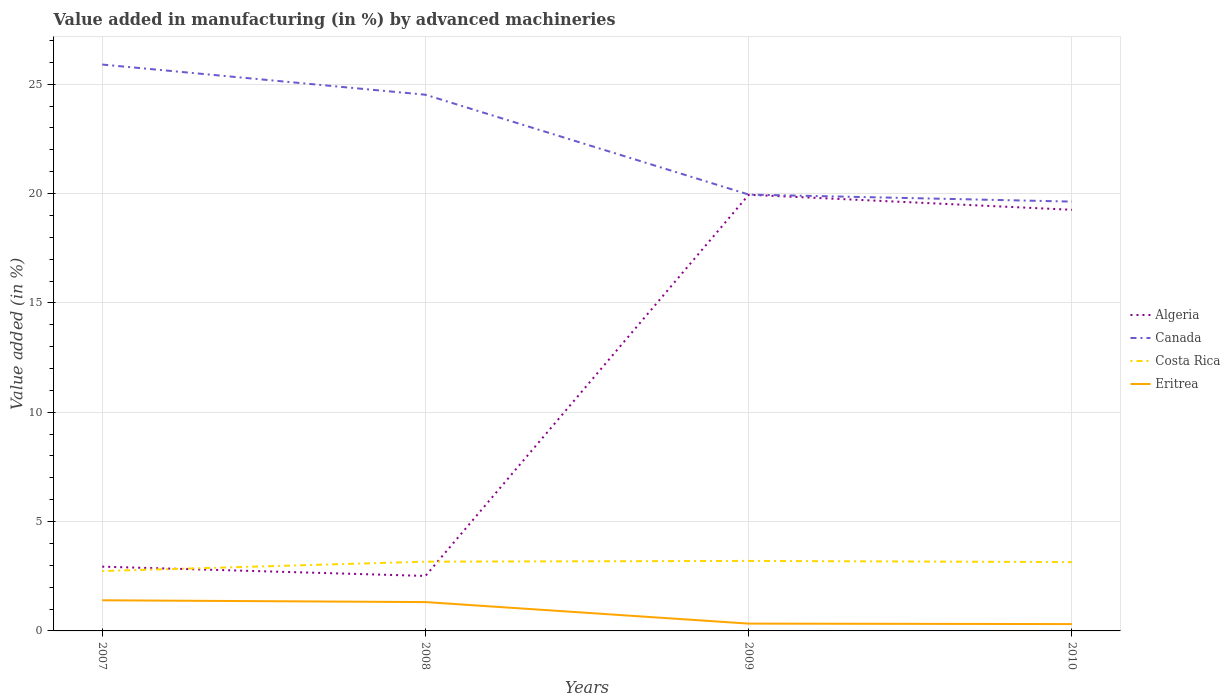How many different coloured lines are there?
Your response must be concise. 4. Does the line corresponding to Canada intersect with the line corresponding to Algeria?
Offer a very short reply. No. Across all years, what is the maximum percentage of value added in manufacturing by advanced machineries in Canada?
Your answer should be compact. 19.63. In which year was the percentage of value added in manufacturing by advanced machineries in Canada maximum?
Offer a terse response. 2010. What is the total percentage of value added in manufacturing by advanced machineries in Canada in the graph?
Your response must be concise. 4.57. What is the difference between the highest and the second highest percentage of value added in manufacturing by advanced machineries in Canada?
Provide a succinct answer. 6.27. What is the difference between the highest and the lowest percentage of value added in manufacturing by advanced machineries in Costa Rica?
Your answer should be very brief. 3. Does the graph contain any zero values?
Offer a terse response. No. How many legend labels are there?
Provide a succinct answer. 4. How are the legend labels stacked?
Offer a very short reply. Vertical. What is the title of the graph?
Provide a succinct answer. Value added in manufacturing (in %) by advanced machineries. Does "Puerto Rico" appear as one of the legend labels in the graph?
Offer a terse response. No. What is the label or title of the X-axis?
Make the answer very short. Years. What is the label or title of the Y-axis?
Provide a succinct answer. Value added (in %). What is the Value added (in %) of Algeria in 2007?
Offer a terse response. 2.94. What is the Value added (in %) in Canada in 2007?
Your answer should be very brief. 25.9. What is the Value added (in %) in Costa Rica in 2007?
Give a very brief answer. 2.74. What is the Value added (in %) of Eritrea in 2007?
Offer a terse response. 1.4. What is the Value added (in %) in Algeria in 2008?
Offer a terse response. 2.51. What is the Value added (in %) in Canada in 2008?
Ensure brevity in your answer.  24.52. What is the Value added (in %) of Costa Rica in 2008?
Provide a short and direct response. 3.17. What is the Value added (in %) of Eritrea in 2008?
Provide a succinct answer. 1.32. What is the Value added (in %) of Algeria in 2009?
Provide a short and direct response. 19.95. What is the Value added (in %) of Canada in 2009?
Provide a short and direct response. 19.96. What is the Value added (in %) in Costa Rica in 2009?
Ensure brevity in your answer.  3.2. What is the Value added (in %) in Eritrea in 2009?
Give a very brief answer. 0.33. What is the Value added (in %) in Algeria in 2010?
Make the answer very short. 19.26. What is the Value added (in %) of Canada in 2010?
Your response must be concise. 19.63. What is the Value added (in %) of Costa Rica in 2010?
Provide a short and direct response. 3.15. What is the Value added (in %) in Eritrea in 2010?
Your answer should be compact. 0.31. Across all years, what is the maximum Value added (in %) in Algeria?
Offer a very short reply. 19.95. Across all years, what is the maximum Value added (in %) in Canada?
Your answer should be compact. 25.9. Across all years, what is the maximum Value added (in %) of Costa Rica?
Offer a very short reply. 3.2. Across all years, what is the maximum Value added (in %) in Eritrea?
Your response must be concise. 1.4. Across all years, what is the minimum Value added (in %) of Algeria?
Keep it short and to the point. 2.51. Across all years, what is the minimum Value added (in %) of Canada?
Provide a short and direct response. 19.63. Across all years, what is the minimum Value added (in %) of Costa Rica?
Offer a very short reply. 2.74. Across all years, what is the minimum Value added (in %) of Eritrea?
Your answer should be very brief. 0.31. What is the total Value added (in %) in Algeria in the graph?
Your answer should be compact. 44.66. What is the total Value added (in %) of Canada in the graph?
Your answer should be compact. 90.01. What is the total Value added (in %) in Costa Rica in the graph?
Provide a succinct answer. 12.25. What is the total Value added (in %) in Eritrea in the graph?
Provide a succinct answer. 3.37. What is the difference between the Value added (in %) in Algeria in 2007 and that in 2008?
Offer a very short reply. 0.42. What is the difference between the Value added (in %) of Canada in 2007 and that in 2008?
Keep it short and to the point. 1.38. What is the difference between the Value added (in %) of Costa Rica in 2007 and that in 2008?
Give a very brief answer. -0.43. What is the difference between the Value added (in %) of Eritrea in 2007 and that in 2008?
Make the answer very short. 0.08. What is the difference between the Value added (in %) in Algeria in 2007 and that in 2009?
Your answer should be very brief. -17.01. What is the difference between the Value added (in %) of Canada in 2007 and that in 2009?
Make the answer very short. 5.95. What is the difference between the Value added (in %) of Costa Rica in 2007 and that in 2009?
Give a very brief answer. -0.46. What is the difference between the Value added (in %) of Eritrea in 2007 and that in 2009?
Your answer should be compact. 1.07. What is the difference between the Value added (in %) of Algeria in 2007 and that in 2010?
Your answer should be compact. -16.32. What is the difference between the Value added (in %) in Canada in 2007 and that in 2010?
Provide a succinct answer. 6.27. What is the difference between the Value added (in %) in Costa Rica in 2007 and that in 2010?
Provide a short and direct response. -0.41. What is the difference between the Value added (in %) of Eritrea in 2007 and that in 2010?
Your response must be concise. 1.09. What is the difference between the Value added (in %) of Algeria in 2008 and that in 2009?
Provide a short and direct response. -17.43. What is the difference between the Value added (in %) of Canada in 2008 and that in 2009?
Make the answer very short. 4.57. What is the difference between the Value added (in %) of Costa Rica in 2008 and that in 2009?
Keep it short and to the point. -0.03. What is the difference between the Value added (in %) in Eritrea in 2008 and that in 2009?
Keep it short and to the point. 0.98. What is the difference between the Value added (in %) in Algeria in 2008 and that in 2010?
Offer a terse response. -16.74. What is the difference between the Value added (in %) of Canada in 2008 and that in 2010?
Offer a very short reply. 4.89. What is the difference between the Value added (in %) of Costa Rica in 2008 and that in 2010?
Keep it short and to the point. 0.02. What is the difference between the Value added (in %) in Algeria in 2009 and that in 2010?
Keep it short and to the point. 0.69. What is the difference between the Value added (in %) of Canada in 2009 and that in 2010?
Make the answer very short. 0.32. What is the difference between the Value added (in %) of Costa Rica in 2009 and that in 2010?
Your response must be concise. 0.05. What is the difference between the Value added (in %) in Eritrea in 2009 and that in 2010?
Make the answer very short. 0.02. What is the difference between the Value added (in %) of Algeria in 2007 and the Value added (in %) of Canada in 2008?
Ensure brevity in your answer.  -21.58. What is the difference between the Value added (in %) of Algeria in 2007 and the Value added (in %) of Costa Rica in 2008?
Your response must be concise. -0.23. What is the difference between the Value added (in %) of Algeria in 2007 and the Value added (in %) of Eritrea in 2008?
Keep it short and to the point. 1.62. What is the difference between the Value added (in %) of Canada in 2007 and the Value added (in %) of Costa Rica in 2008?
Offer a terse response. 22.73. What is the difference between the Value added (in %) of Canada in 2007 and the Value added (in %) of Eritrea in 2008?
Give a very brief answer. 24.58. What is the difference between the Value added (in %) in Costa Rica in 2007 and the Value added (in %) in Eritrea in 2008?
Make the answer very short. 1.42. What is the difference between the Value added (in %) of Algeria in 2007 and the Value added (in %) of Canada in 2009?
Your response must be concise. -17.02. What is the difference between the Value added (in %) of Algeria in 2007 and the Value added (in %) of Costa Rica in 2009?
Keep it short and to the point. -0.26. What is the difference between the Value added (in %) of Algeria in 2007 and the Value added (in %) of Eritrea in 2009?
Your response must be concise. 2.6. What is the difference between the Value added (in %) in Canada in 2007 and the Value added (in %) in Costa Rica in 2009?
Your answer should be very brief. 22.7. What is the difference between the Value added (in %) in Canada in 2007 and the Value added (in %) in Eritrea in 2009?
Provide a succinct answer. 25.57. What is the difference between the Value added (in %) of Costa Rica in 2007 and the Value added (in %) of Eritrea in 2009?
Offer a very short reply. 2.4. What is the difference between the Value added (in %) in Algeria in 2007 and the Value added (in %) in Canada in 2010?
Give a very brief answer. -16.69. What is the difference between the Value added (in %) of Algeria in 2007 and the Value added (in %) of Costa Rica in 2010?
Offer a very short reply. -0.21. What is the difference between the Value added (in %) of Algeria in 2007 and the Value added (in %) of Eritrea in 2010?
Make the answer very short. 2.63. What is the difference between the Value added (in %) in Canada in 2007 and the Value added (in %) in Costa Rica in 2010?
Offer a very short reply. 22.75. What is the difference between the Value added (in %) of Canada in 2007 and the Value added (in %) of Eritrea in 2010?
Ensure brevity in your answer.  25.59. What is the difference between the Value added (in %) in Costa Rica in 2007 and the Value added (in %) in Eritrea in 2010?
Keep it short and to the point. 2.43. What is the difference between the Value added (in %) of Algeria in 2008 and the Value added (in %) of Canada in 2009?
Keep it short and to the point. -17.44. What is the difference between the Value added (in %) of Algeria in 2008 and the Value added (in %) of Costa Rica in 2009?
Your response must be concise. -0.69. What is the difference between the Value added (in %) of Algeria in 2008 and the Value added (in %) of Eritrea in 2009?
Make the answer very short. 2.18. What is the difference between the Value added (in %) of Canada in 2008 and the Value added (in %) of Costa Rica in 2009?
Keep it short and to the point. 21.32. What is the difference between the Value added (in %) of Canada in 2008 and the Value added (in %) of Eritrea in 2009?
Ensure brevity in your answer.  24.19. What is the difference between the Value added (in %) of Costa Rica in 2008 and the Value added (in %) of Eritrea in 2009?
Provide a short and direct response. 2.83. What is the difference between the Value added (in %) of Algeria in 2008 and the Value added (in %) of Canada in 2010?
Offer a terse response. -17.12. What is the difference between the Value added (in %) of Algeria in 2008 and the Value added (in %) of Costa Rica in 2010?
Your answer should be very brief. -0.63. What is the difference between the Value added (in %) of Algeria in 2008 and the Value added (in %) of Eritrea in 2010?
Your answer should be compact. 2.2. What is the difference between the Value added (in %) in Canada in 2008 and the Value added (in %) in Costa Rica in 2010?
Give a very brief answer. 21.37. What is the difference between the Value added (in %) of Canada in 2008 and the Value added (in %) of Eritrea in 2010?
Your answer should be compact. 24.21. What is the difference between the Value added (in %) of Costa Rica in 2008 and the Value added (in %) of Eritrea in 2010?
Offer a terse response. 2.85. What is the difference between the Value added (in %) in Algeria in 2009 and the Value added (in %) in Canada in 2010?
Provide a short and direct response. 0.31. What is the difference between the Value added (in %) in Algeria in 2009 and the Value added (in %) in Costa Rica in 2010?
Your answer should be very brief. 16.8. What is the difference between the Value added (in %) of Algeria in 2009 and the Value added (in %) of Eritrea in 2010?
Give a very brief answer. 19.63. What is the difference between the Value added (in %) of Canada in 2009 and the Value added (in %) of Costa Rica in 2010?
Offer a terse response. 16.81. What is the difference between the Value added (in %) of Canada in 2009 and the Value added (in %) of Eritrea in 2010?
Keep it short and to the point. 19.64. What is the difference between the Value added (in %) of Costa Rica in 2009 and the Value added (in %) of Eritrea in 2010?
Provide a short and direct response. 2.89. What is the average Value added (in %) in Algeria per year?
Provide a succinct answer. 11.16. What is the average Value added (in %) of Canada per year?
Keep it short and to the point. 22.5. What is the average Value added (in %) of Costa Rica per year?
Your answer should be very brief. 3.06. What is the average Value added (in %) in Eritrea per year?
Make the answer very short. 0.84. In the year 2007, what is the difference between the Value added (in %) in Algeria and Value added (in %) in Canada?
Your answer should be very brief. -22.96. In the year 2007, what is the difference between the Value added (in %) in Algeria and Value added (in %) in Costa Rica?
Offer a terse response. 0.2. In the year 2007, what is the difference between the Value added (in %) of Algeria and Value added (in %) of Eritrea?
Give a very brief answer. 1.54. In the year 2007, what is the difference between the Value added (in %) of Canada and Value added (in %) of Costa Rica?
Keep it short and to the point. 23.16. In the year 2007, what is the difference between the Value added (in %) in Canada and Value added (in %) in Eritrea?
Give a very brief answer. 24.5. In the year 2007, what is the difference between the Value added (in %) of Costa Rica and Value added (in %) of Eritrea?
Keep it short and to the point. 1.34. In the year 2008, what is the difference between the Value added (in %) of Algeria and Value added (in %) of Canada?
Keep it short and to the point. -22.01. In the year 2008, what is the difference between the Value added (in %) in Algeria and Value added (in %) in Costa Rica?
Your answer should be very brief. -0.65. In the year 2008, what is the difference between the Value added (in %) in Algeria and Value added (in %) in Eritrea?
Offer a terse response. 1.2. In the year 2008, what is the difference between the Value added (in %) in Canada and Value added (in %) in Costa Rica?
Provide a succinct answer. 21.35. In the year 2008, what is the difference between the Value added (in %) in Canada and Value added (in %) in Eritrea?
Provide a succinct answer. 23.2. In the year 2008, what is the difference between the Value added (in %) of Costa Rica and Value added (in %) of Eritrea?
Your response must be concise. 1.85. In the year 2009, what is the difference between the Value added (in %) of Algeria and Value added (in %) of Canada?
Ensure brevity in your answer.  -0.01. In the year 2009, what is the difference between the Value added (in %) of Algeria and Value added (in %) of Costa Rica?
Ensure brevity in your answer.  16.75. In the year 2009, what is the difference between the Value added (in %) of Algeria and Value added (in %) of Eritrea?
Your answer should be very brief. 19.61. In the year 2009, what is the difference between the Value added (in %) in Canada and Value added (in %) in Costa Rica?
Give a very brief answer. 16.75. In the year 2009, what is the difference between the Value added (in %) of Canada and Value added (in %) of Eritrea?
Your response must be concise. 19.62. In the year 2009, what is the difference between the Value added (in %) of Costa Rica and Value added (in %) of Eritrea?
Your response must be concise. 2.87. In the year 2010, what is the difference between the Value added (in %) of Algeria and Value added (in %) of Canada?
Make the answer very short. -0.38. In the year 2010, what is the difference between the Value added (in %) of Algeria and Value added (in %) of Costa Rica?
Your answer should be very brief. 16.11. In the year 2010, what is the difference between the Value added (in %) of Algeria and Value added (in %) of Eritrea?
Your response must be concise. 18.94. In the year 2010, what is the difference between the Value added (in %) in Canada and Value added (in %) in Costa Rica?
Offer a very short reply. 16.49. In the year 2010, what is the difference between the Value added (in %) of Canada and Value added (in %) of Eritrea?
Provide a succinct answer. 19.32. In the year 2010, what is the difference between the Value added (in %) of Costa Rica and Value added (in %) of Eritrea?
Provide a succinct answer. 2.83. What is the ratio of the Value added (in %) of Algeria in 2007 to that in 2008?
Give a very brief answer. 1.17. What is the ratio of the Value added (in %) in Canada in 2007 to that in 2008?
Ensure brevity in your answer.  1.06. What is the ratio of the Value added (in %) of Costa Rica in 2007 to that in 2008?
Keep it short and to the point. 0.86. What is the ratio of the Value added (in %) in Eritrea in 2007 to that in 2008?
Offer a very short reply. 1.06. What is the ratio of the Value added (in %) of Algeria in 2007 to that in 2009?
Offer a terse response. 0.15. What is the ratio of the Value added (in %) in Canada in 2007 to that in 2009?
Offer a terse response. 1.3. What is the ratio of the Value added (in %) of Costa Rica in 2007 to that in 2009?
Your answer should be very brief. 0.86. What is the ratio of the Value added (in %) in Eritrea in 2007 to that in 2009?
Offer a very short reply. 4.19. What is the ratio of the Value added (in %) in Algeria in 2007 to that in 2010?
Your answer should be compact. 0.15. What is the ratio of the Value added (in %) in Canada in 2007 to that in 2010?
Offer a terse response. 1.32. What is the ratio of the Value added (in %) in Costa Rica in 2007 to that in 2010?
Give a very brief answer. 0.87. What is the ratio of the Value added (in %) in Eritrea in 2007 to that in 2010?
Provide a short and direct response. 4.47. What is the ratio of the Value added (in %) of Algeria in 2008 to that in 2009?
Offer a terse response. 0.13. What is the ratio of the Value added (in %) in Canada in 2008 to that in 2009?
Make the answer very short. 1.23. What is the ratio of the Value added (in %) of Costa Rica in 2008 to that in 2009?
Offer a very short reply. 0.99. What is the ratio of the Value added (in %) in Eritrea in 2008 to that in 2009?
Give a very brief answer. 3.94. What is the ratio of the Value added (in %) in Algeria in 2008 to that in 2010?
Ensure brevity in your answer.  0.13. What is the ratio of the Value added (in %) in Canada in 2008 to that in 2010?
Ensure brevity in your answer.  1.25. What is the ratio of the Value added (in %) in Costa Rica in 2008 to that in 2010?
Make the answer very short. 1.01. What is the ratio of the Value added (in %) in Eritrea in 2008 to that in 2010?
Make the answer very short. 4.21. What is the ratio of the Value added (in %) in Algeria in 2009 to that in 2010?
Make the answer very short. 1.04. What is the ratio of the Value added (in %) in Canada in 2009 to that in 2010?
Your response must be concise. 1.02. What is the ratio of the Value added (in %) in Costa Rica in 2009 to that in 2010?
Offer a terse response. 1.02. What is the ratio of the Value added (in %) in Eritrea in 2009 to that in 2010?
Ensure brevity in your answer.  1.07. What is the difference between the highest and the second highest Value added (in %) of Algeria?
Make the answer very short. 0.69. What is the difference between the highest and the second highest Value added (in %) of Canada?
Offer a terse response. 1.38. What is the difference between the highest and the second highest Value added (in %) in Costa Rica?
Your answer should be very brief. 0.03. What is the difference between the highest and the second highest Value added (in %) of Eritrea?
Provide a short and direct response. 0.08. What is the difference between the highest and the lowest Value added (in %) in Algeria?
Give a very brief answer. 17.43. What is the difference between the highest and the lowest Value added (in %) of Canada?
Provide a succinct answer. 6.27. What is the difference between the highest and the lowest Value added (in %) of Costa Rica?
Your answer should be compact. 0.46. What is the difference between the highest and the lowest Value added (in %) of Eritrea?
Your answer should be very brief. 1.09. 